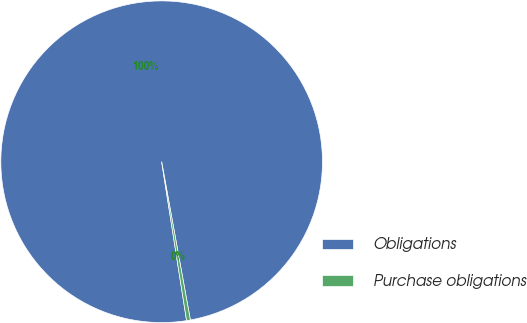Convert chart. <chart><loc_0><loc_0><loc_500><loc_500><pie_chart><fcel>Obligations<fcel>Purchase obligations<nl><fcel>99.62%<fcel>0.38%<nl></chart> 